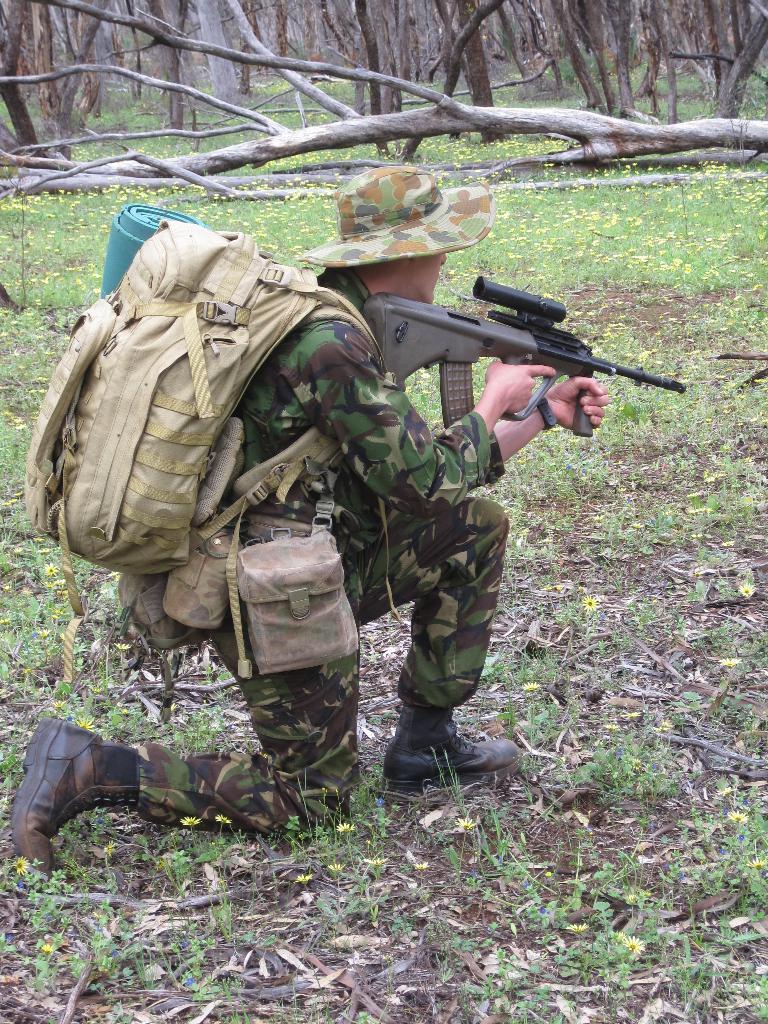Please provide a concise description of this image. In this image, we can see a person carrying a bag and holding a gun. We can see the ground covered with grass and plants. We can also see some trees. 